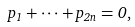Convert formula to latex. <formula><loc_0><loc_0><loc_500><loc_500>p _ { 1 } + \cdots + p _ { 2 n } = 0 ,</formula> 